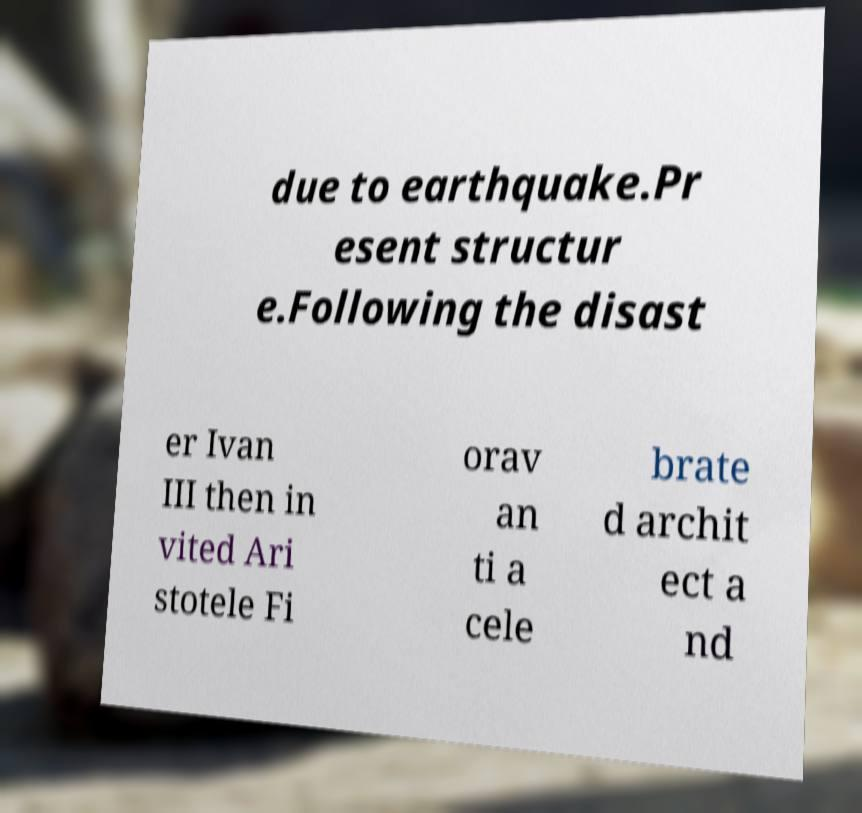What messages or text are displayed in this image? I need them in a readable, typed format. due to earthquake.Pr esent structur e.Following the disast er Ivan III then in vited Ari stotele Fi orav an ti a cele brate d archit ect a nd 